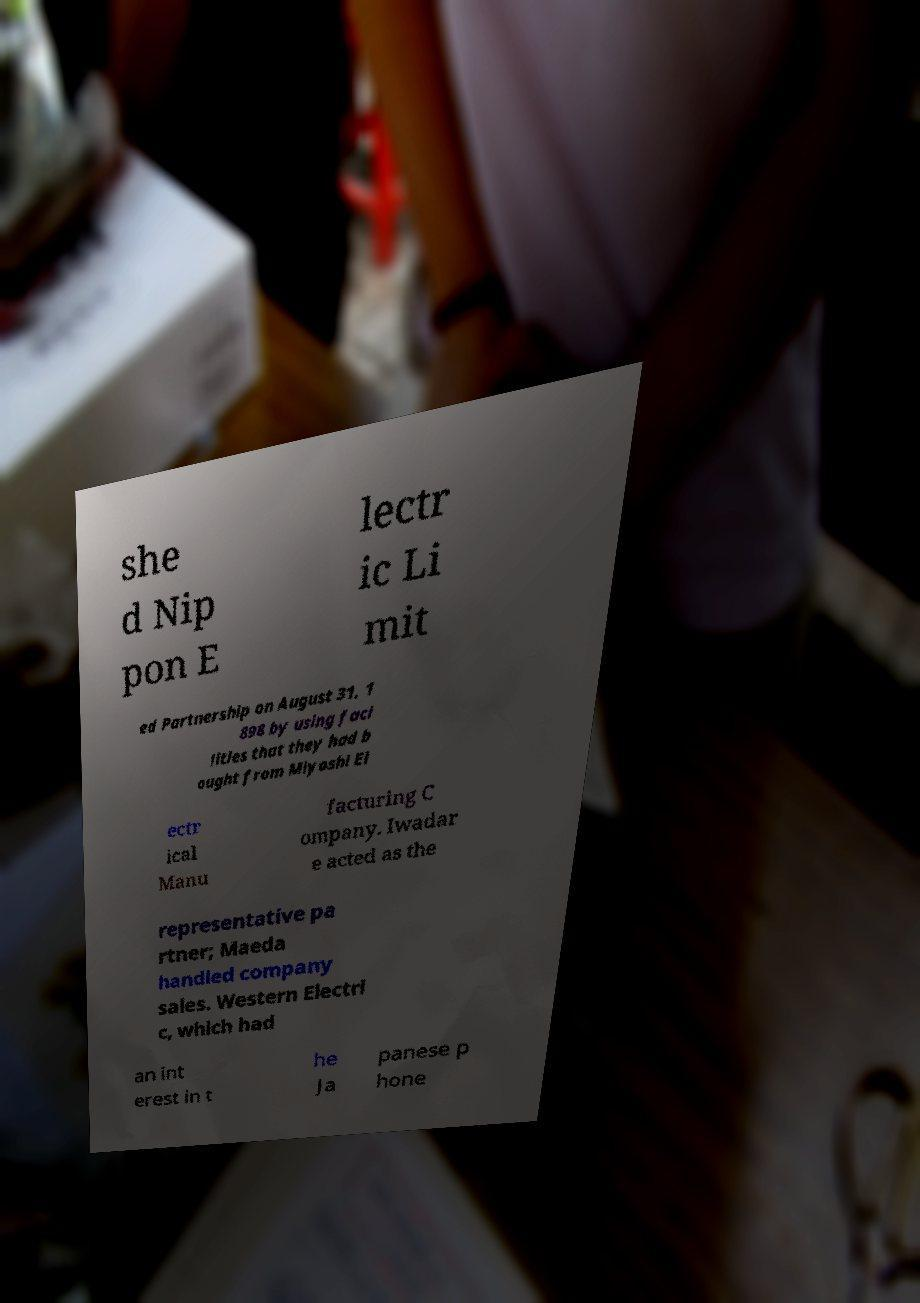Can you read and provide the text displayed in the image?This photo seems to have some interesting text. Can you extract and type it out for me? she d Nip pon E lectr ic Li mit ed Partnership on August 31, 1 898 by using faci lities that they had b ought from Miyoshi El ectr ical Manu facturing C ompany. Iwadar e acted as the representative pa rtner; Maeda handled company sales. Western Electri c, which had an int erest in t he Ja panese p hone 